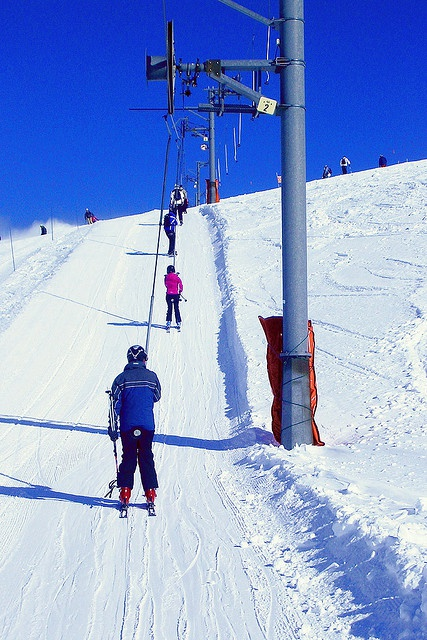Describe the objects in this image and their specific colors. I can see people in blue, navy, darkblue, and white tones, people in blue, navy, and purple tones, people in blue, navy, and darkblue tones, people in blue, navy, white, and gray tones, and skis in blue, navy, lightgray, and gray tones in this image. 